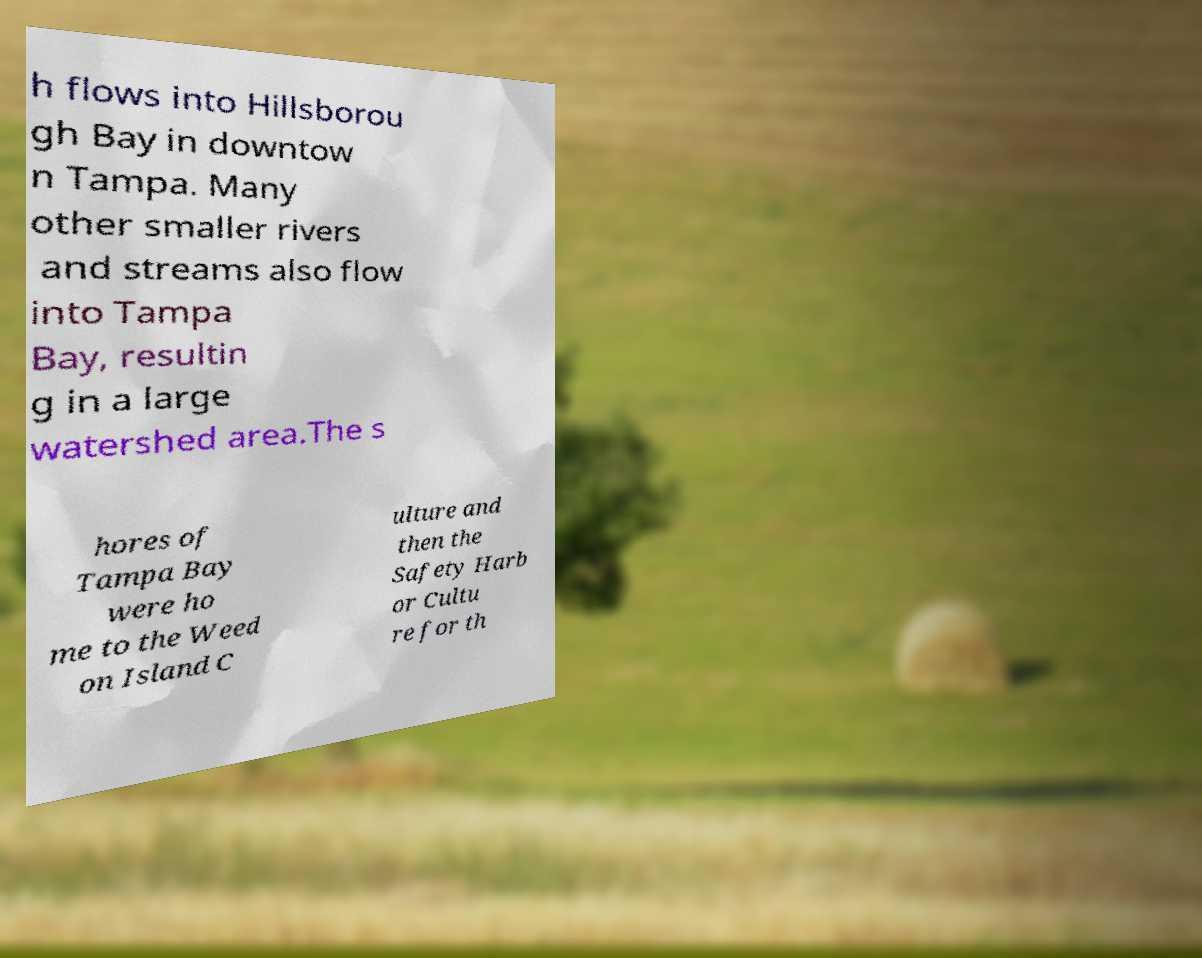For documentation purposes, I need the text within this image transcribed. Could you provide that? h flows into Hillsborou gh Bay in downtow n Tampa. Many other smaller rivers and streams also flow into Tampa Bay, resultin g in a large watershed area.The s hores of Tampa Bay were ho me to the Weed on Island C ulture and then the Safety Harb or Cultu re for th 